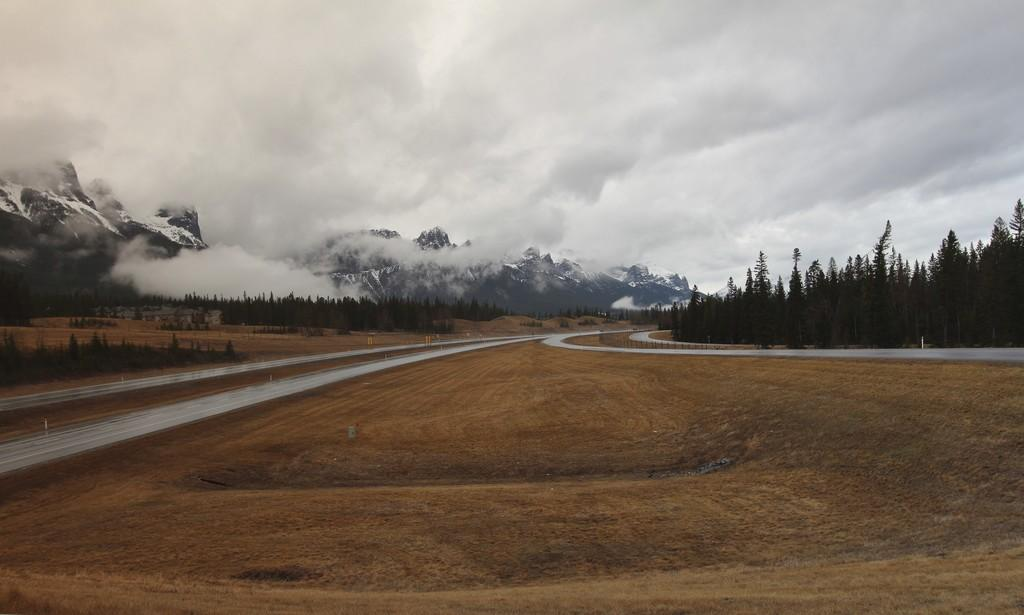What type of surface can be seen in the image? There is ground visible in the image. What type of transportation infrastructure is present in the image? There is a road in the image. What safety feature is present near the road? There is a railing near the road. What type of vegetation is present in the image? There are many trees in the image. What geographical features can be seen in the background of the image? There are mountains in the background of the image. What weather condition is present in the background of the image? There is fog in the background of the image. What part of the natural environment is visible in the background of the image? The sky is visible in the background of the image. What type of skirt is being worn by the mountain in the image? There are no people or clothing items present in the image, only geographical features like mountains. 